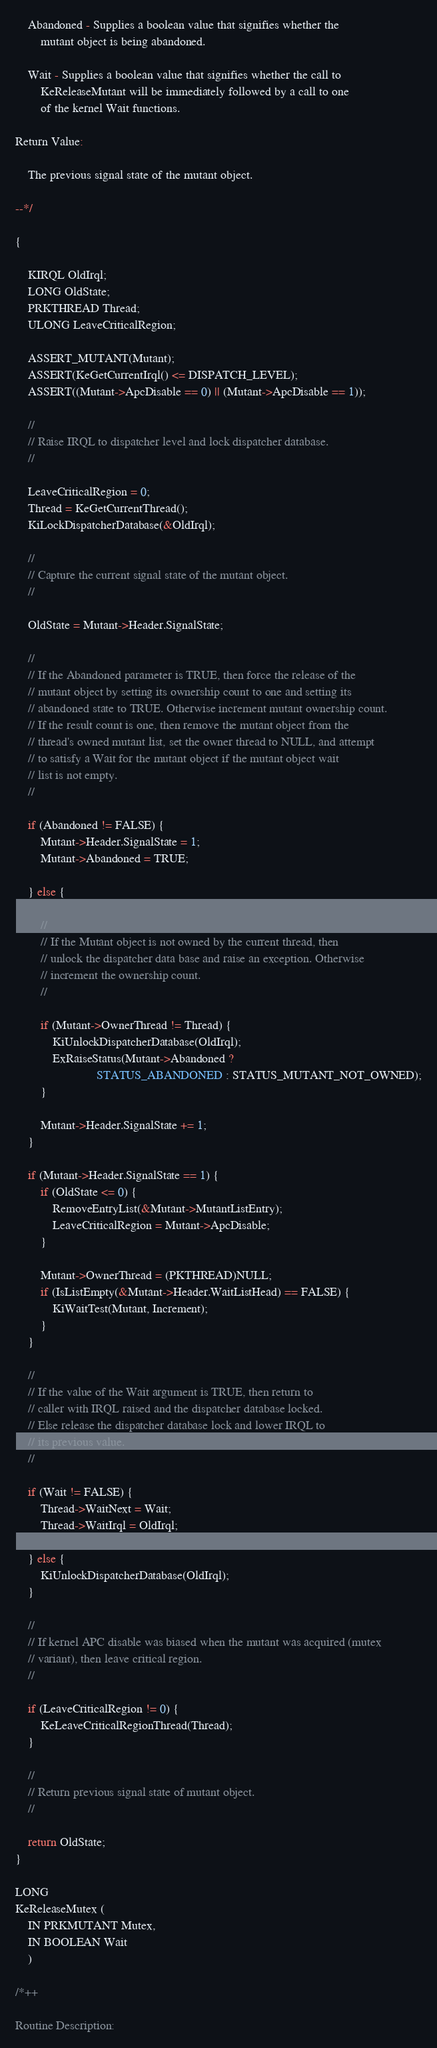Convert code to text. <code><loc_0><loc_0><loc_500><loc_500><_C_>
    Abandoned - Supplies a boolean value that signifies whether the
        mutant object is being abandoned.

    Wait - Supplies a boolean value that signifies whether the call to
        KeReleaseMutant will be immediately followed by a call to one
        of the kernel Wait functions.

Return Value:

    The previous signal state of the mutant object.

--*/

{

    KIRQL OldIrql;
    LONG OldState;
    PRKTHREAD Thread;
    ULONG LeaveCriticalRegion;

    ASSERT_MUTANT(Mutant);
    ASSERT(KeGetCurrentIrql() <= DISPATCH_LEVEL);
    ASSERT((Mutant->ApcDisable == 0) || (Mutant->ApcDisable == 1));

    //
    // Raise IRQL to dispatcher level and lock dispatcher database.
    //

    LeaveCriticalRegion = 0;
    Thread = KeGetCurrentThread();
    KiLockDispatcherDatabase(&OldIrql);

    //
    // Capture the current signal state of the mutant object.
    //

    OldState = Mutant->Header.SignalState;

    //
    // If the Abandoned parameter is TRUE, then force the release of the
    // mutant object by setting its ownership count to one and setting its
    // abandoned state to TRUE. Otherwise increment mutant ownership count.
    // If the result count is one, then remove the mutant object from the
    // thread's owned mutant list, set the owner thread to NULL, and attempt
    // to satisfy a Wait for the mutant object if the mutant object wait
    // list is not empty.
    //

    if (Abandoned != FALSE) {
        Mutant->Header.SignalState = 1;
        Mutant->Abandoned = TRUE;

    } else {

        //
        // If the Mutant object is not owned by the current thread, then
        // unlock the dispatcher data base and raise an exception. Otherwise
        // increment the ownership count.
        //

        if (Mutant->OwnerThread != Thread) {
            KiUnlockDispatcherDatabase(OldIrql);
            ExRaiseStatus(Mutant->Abandoned ?
                          STATUS_ABANDONED : STATUS_MUTANT_NOT_OWNED);
        }

        Mutant->Header.SignalState += 1;
    }

    if (Mutant->Header.SignalState == 1) {
        if (OldState <= 0) {
            RemoveEntryList(&Mutant->MutantListEntry);
            LeaveCriticalRegion = Mutant->ApcDisable;
        }

        Mutant->OwnerThread = (PKTHREAD)NULL;
        if (IsListEmpty(&Mutant->Header.WaitListHead) == FALSE) {
            KiWaitTest(Mutant, Increment);
        }
    }

    //
    // If the value of the Wait argument is TRUE, then return to
    // caller with IRQL raised and the dispatcher database locked.
    // Else release the dispatcher database lock and lower IRQL to
    // its previous value.
    //

    if (Wait != FALSE) {
        Thread->WaitNext = Wait;
        Thread->WaitIrql = OldIrql;

    } else {
        KiUnlockDispatcherDatabase(OldIrql);
    }

    //
    // If kernel APC disable was biased when the mutant was acquired (mutex
    // variant), then leave critical region.
    //

    if (LeaveCriticalRegion != 0) {
        KeLeaveCriticalRegionThread(Thread);
    }

    //
    // Return previous signal state of mutant object.
    //

    return OldState;
}

LONG
KeReleaseMutex (
    IN PRKMUTANT Mutex,
    IN BOOLEAN Wait
    )

/*++

Routine Description:
</code> 